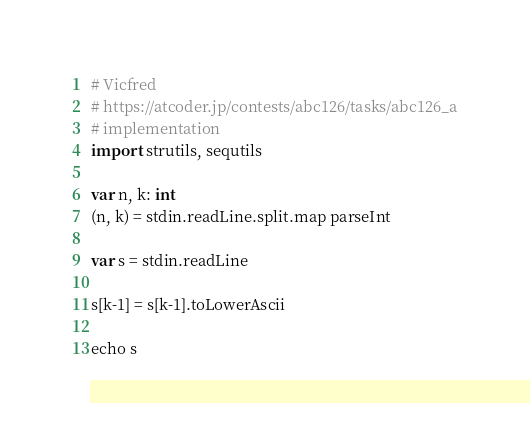Convert code to text. <code><loc_0><loc_0><loc_500><loc_500><_Nim_># Vicfred
# https://atcoder.jp/contests/abc126/tasks/abc126_a
# implementation
import strutils, sequtils

var n, k: int
(n, k) = stdin.readLine.split.map parseInt

var s = stdin.readLine

s[k-1] = s[k-1].toLowerAscii

echo s

</code> 